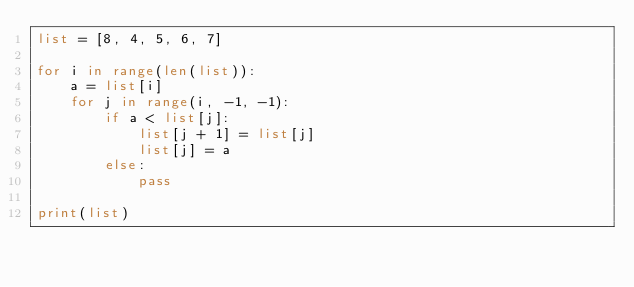Convert code to text. <code><loc_0><loc_0><loc_500><loc_500><_Python_>list = [8, 4, 5, 6, 7]

for i in range(len(list)):
    a = list[i]
    for j in range(i, -1, -1):
        if a < list[j]:
            list[j + 1] = list[j]
            list[j] = a
        else:
            pass

print(list)</code> 